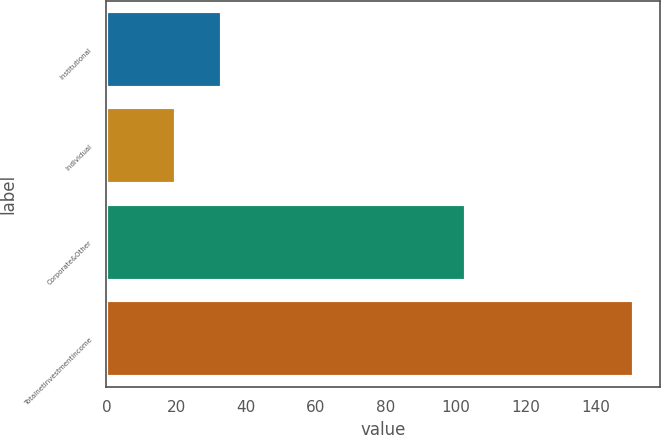Convert chart. <chart><loc_0><loc_0><loc_500><loc_500><bar_chart><fcel>Institutional<fcel>Individual<fcel>Corporate&Other<fcel>Totalnetinvestmentincome<nl><fcel>33.1<fcel>20<fcel>103<fcel>151<nl></chart> 